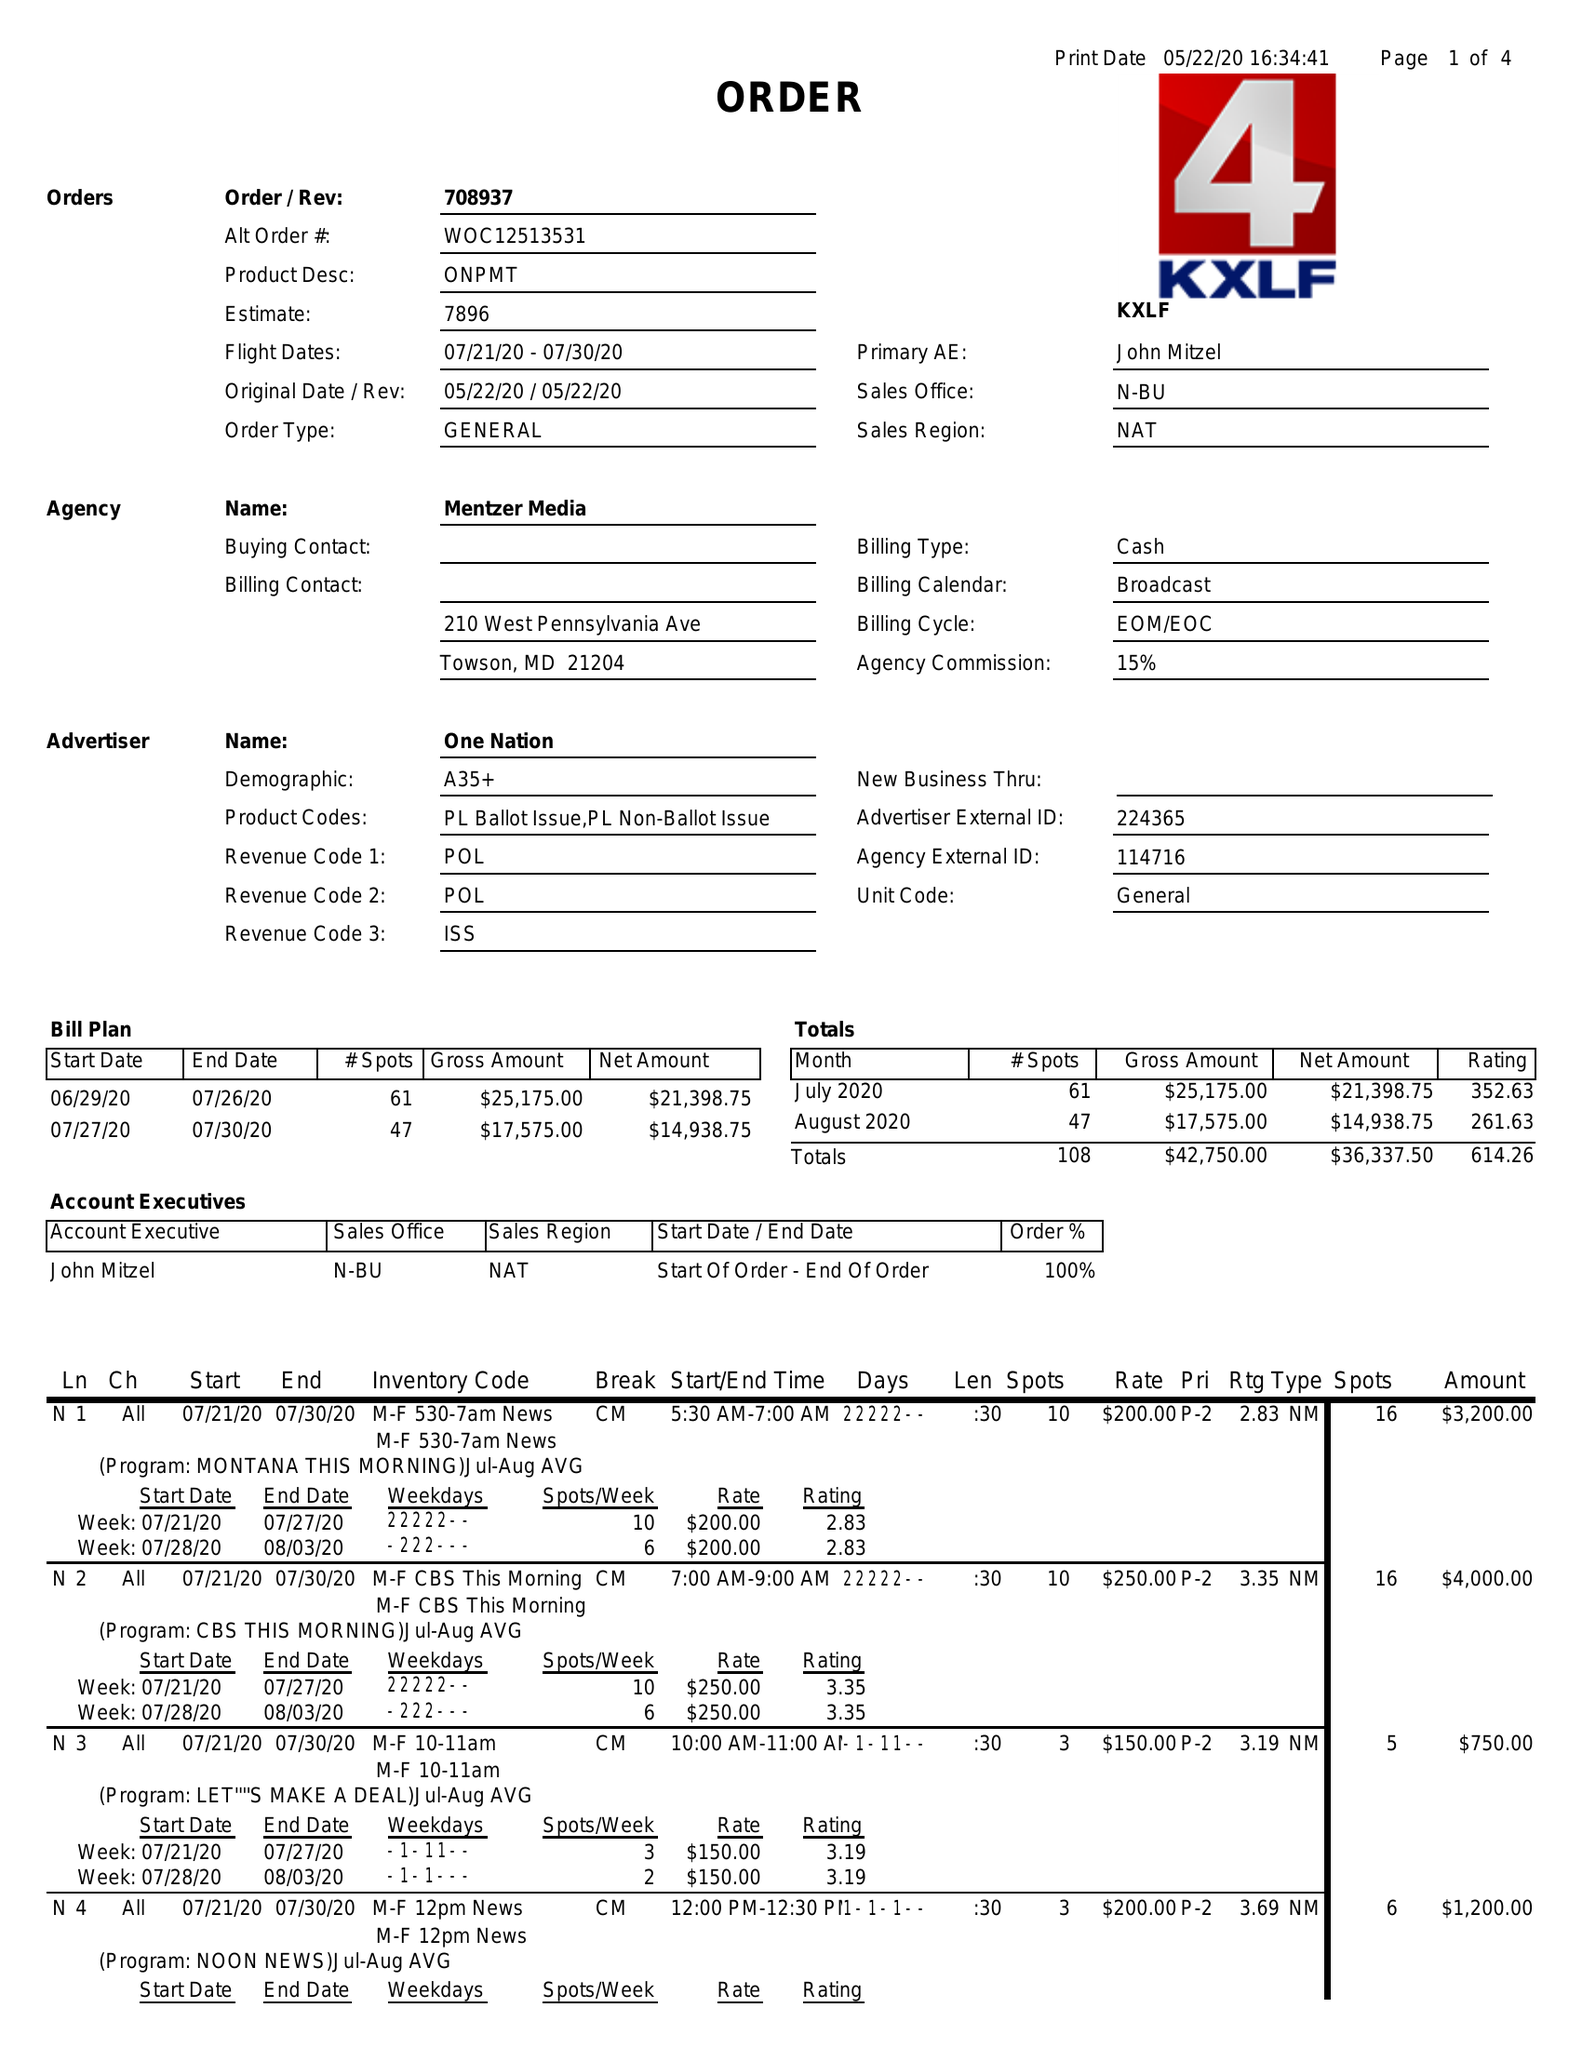What is the value for the advertiser?
Answer the question using a single word or phrase. ONE NATION 